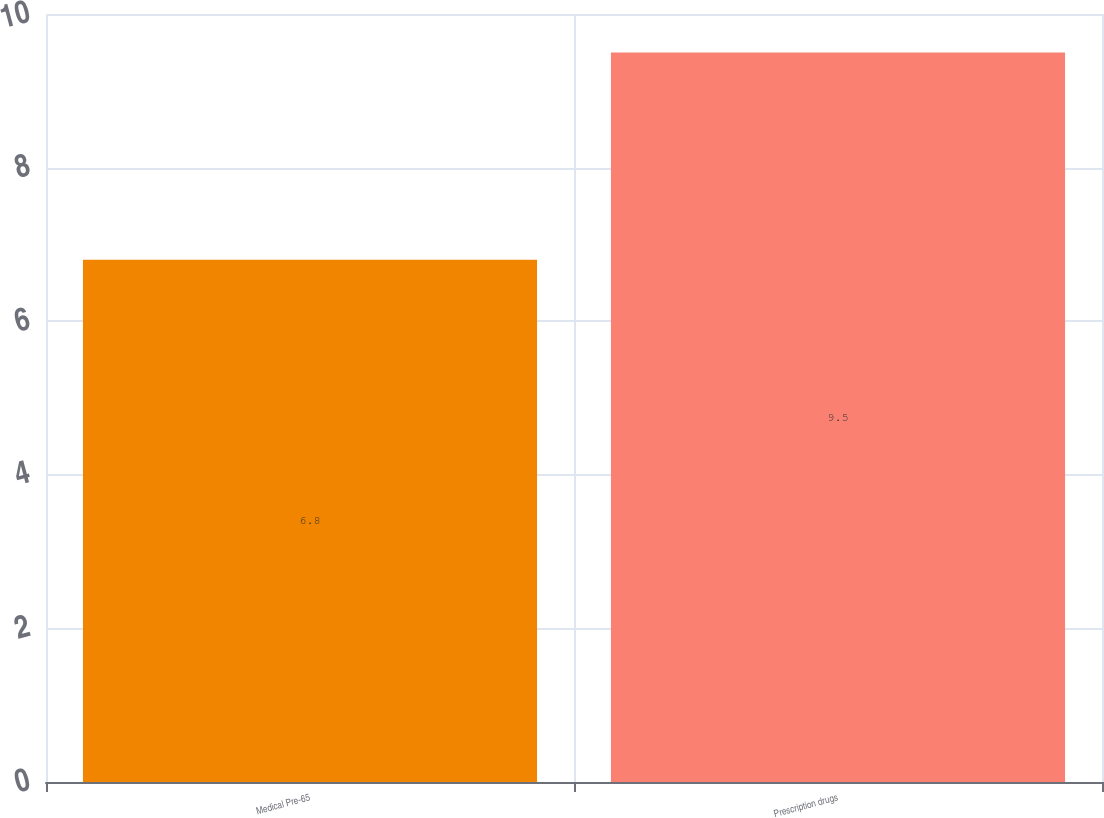Convert chart to OTSL. <chart><loc_0><loc_0><loc_500><loc_500><bar_chart><fcel>Medical Pre-65<fcel>Prescription drugs<nl><fcel>6.8<fcel>9.5<nl></chart> 